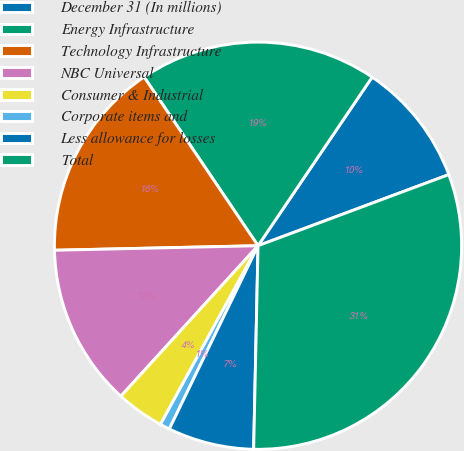Convert chart. <chart><loc_0><loc_0><loc_500><loc_500><pie_chart><fcel>December 31 (In millions)<fcel>Energy Infrastructure<fcel>Technology Infrastructure<fcel>NBC Universal<fcel>Consumer & Industrial<fcel>Corporate items and<fcel>Less allowance for losses<fcel>Total<nl><fcel>9.85%<fcel>18.92%<fcel>15.9%<fcel>12.88%<fcel>3.81%<fcel>0.78%<fcel>6.83%<fcel>31.02%<nl></chart> 